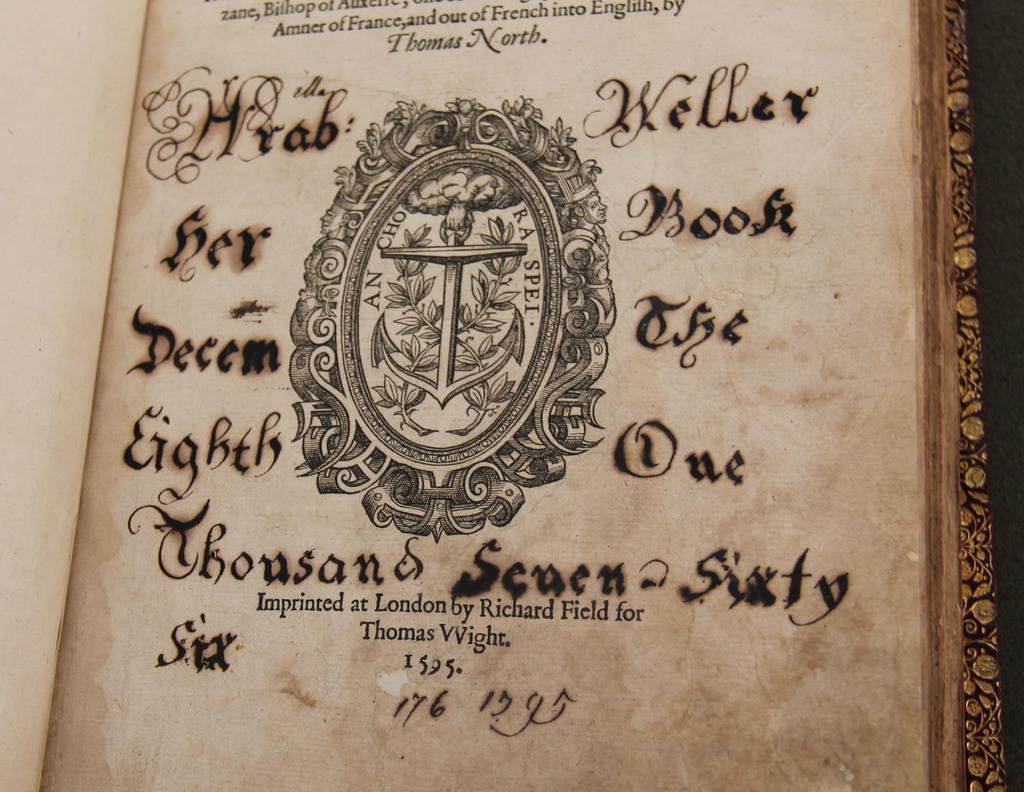When was this publushed?
Offer a very short reply. 1595. 